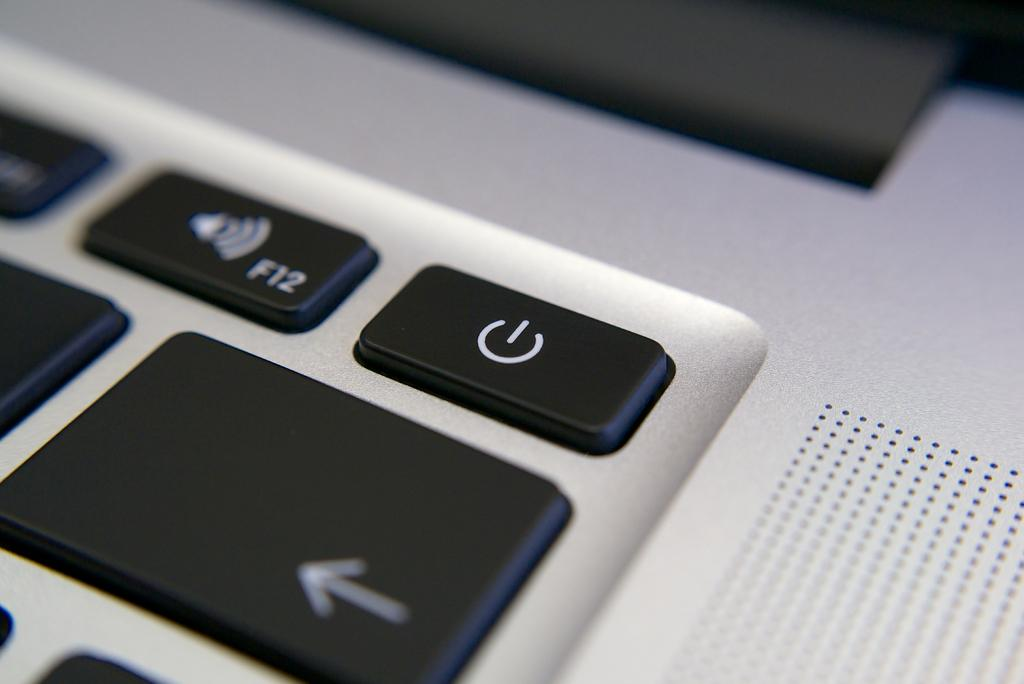Provide a one-sentence caption for the provided image. Keyboard key that says F12 on it next to a power symbol. 